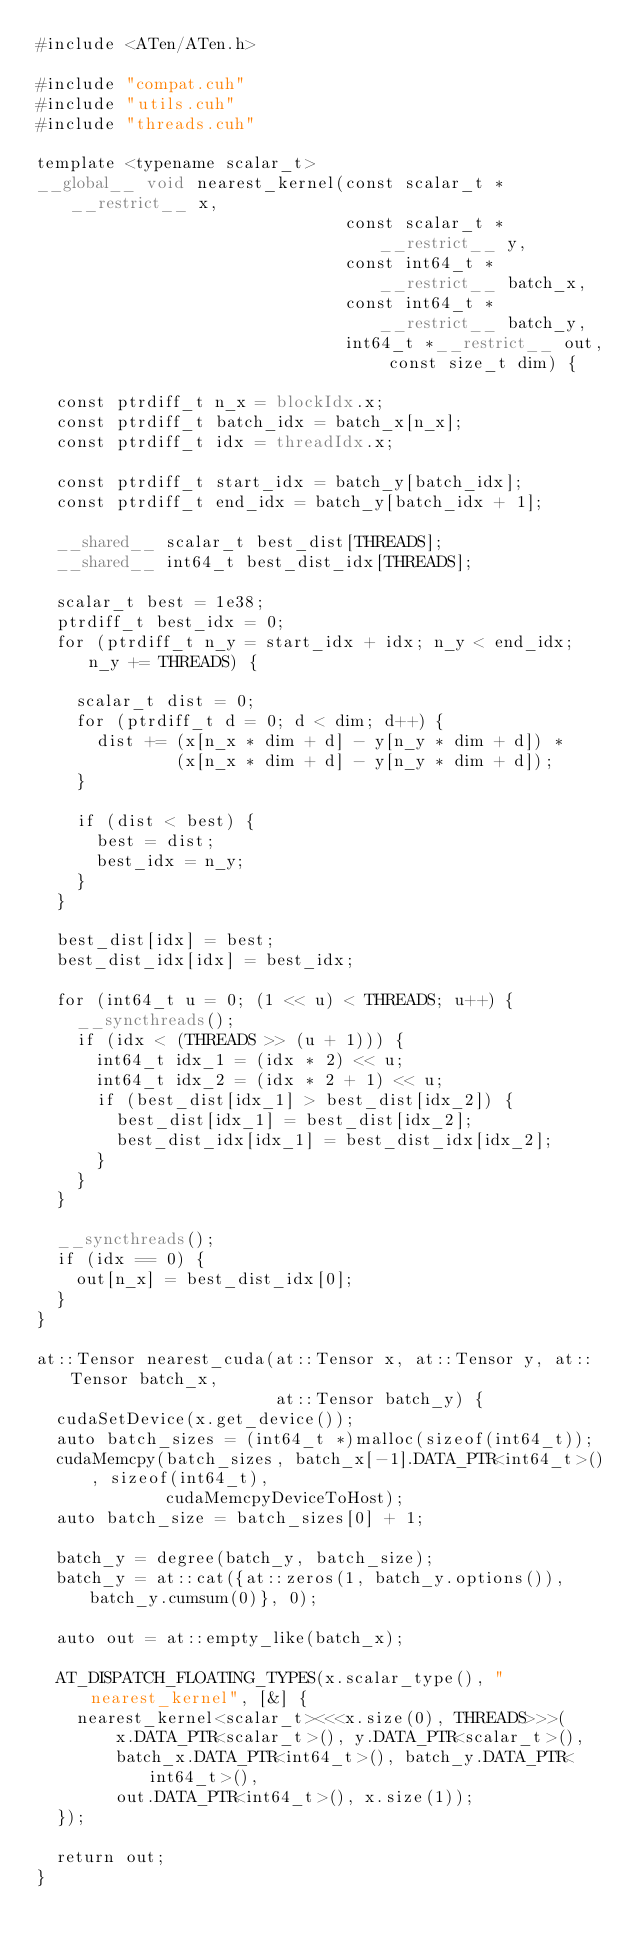<code> <loc_0><loc_0><loc_500><loc_500><_Cuda_>#include <ATen/ATen.h>

#include "compat.cuh"
#include "utils.cuh"
#include "threads.cuh"

template <typename scalar_t>
__global__ void nearest_kernel(const scalar_t *__restrict__ x,
                               const scalar_t *__restrict__ y,
                               const int64_t *__restrict__ batch_x,
                               const int64_t *__restrict__ batch_y,
                               int64_t *__restrict__ out, const size_t dim) {

  const ptrdiff_t n_x = blockIdx.x;
  const ptrdiff_t batch_idx = batch_x[n_x];
  const ptrdiff_t idx = threadIdx.x;

  const ptrdiff_t start_idx = batch_y[batch_idx];
  const ptrdiff_t end_idx = batch_y[batch_idx + 1];

  __shared__ scalar_t best_dist[THREADS];
  __shared__ int64_t best_dist_idx[THREADS];

  scalar_t best = 1e38;
  ptrdiff_t best_idx = 0;
  for (ptrdiff_t n_y = start_idx + idx; n_y < end_idx; n_y += THREADS) {

    scalar_t dist = 0;
    for (ptrdiff_t d = 0; d < dim; d++) {
      dist += (x[n_x * dim + d] - y[n_y * dim + d]) *
              (x[n_x * dim + d] - y[n_y * dim + d]);
    }

    if (dist < best) {
      best = dist;
      best_idx = n_y;
    }
  }

  best_dist[idx] = best;
  best_dist_idx[idx] = best_idx;

  for (int64_t u = 0; (1 << u) < THREADS; u++) {
    __syncthreads();
    if (idx < (THREADS >> (u + 1))) {
      int64_t idx_1 = (idx * 2) << u;
      int64_t idx_2 = (idx * 2 + 1) << u;
      if (best_dist[idx_1] > best_dist[idx_2]) {
        best_dist[idx_1] = best_dist[idx_2];
        best_dist_idx[idx_1] = best_dist_idx[idx_2];
      }
    }
  }

  __syncthreads();
  if (idx == 0) {
    out[n_x] = best_dist_idx[0];
  }
}

at::Tensor nearest_cuda(at::Tensor x, at::Tensor y, at::Tensor batch_x,
                        at::Tensor batch_y) {
  cudaSetDevice(x.get_device());
  auto batch_sizes = (int64_t *)malloc(sizeof(int64_t));
  cudaMemcpy(batch_sizes, batch_x[-1].DATA_PTR<int64_t>(), sizeof(int64_t),
             cudaMemcpyDeviceToHost);
  auto batch_size = batch_sizes[0] + 1;

  batch_y = degree(batch_y, batch_size);
  batch_y = at::cat({at::zeros(1, batch_y.options()), batch_y.cumsum(0)}, 0);

  auto out = at::empty_like(batch_x);

  AT_DISPATCH_FLOATING_TYPES(x.scalar_type(), "nearest_kernel", [&] {
    nearest_kernel<scalar_t><<<x.size(0), THREADS>>>(
        x.DATA_PTR<scalar_t>(), y.DATA_PTR<scalar_t>(),
        batch_x.DATA_PTR<int64_t>(), batch_y.DATA_PTR<int64_t>(),
        out.DATA_PTR<int64_t>(), x.size(1));
  });

  return out;
}
</code> 